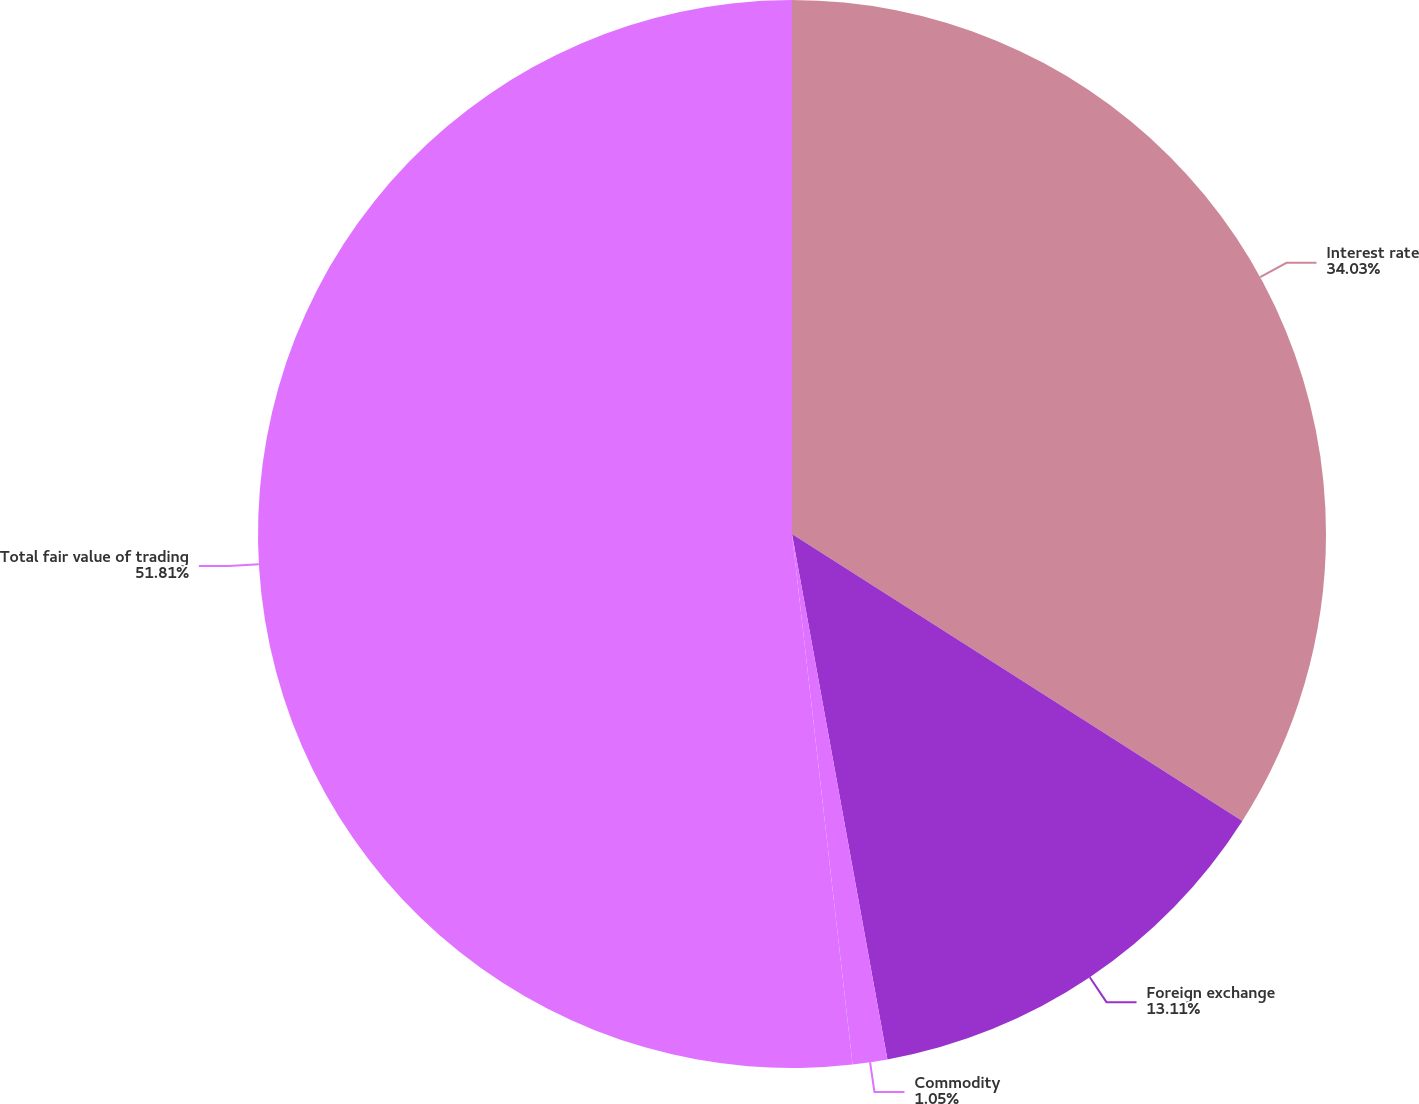Convert chart to OTSL. <chart><loc_0><loc_0><loc_500><loc_500><pie_chart><fcel>Interest rate<fcel>Foreign exchange<fcel>Commodity<fcel>Total fair value of trading<nl><fcel>34.03%<fcel>13.11%<fcel>1.05%<fcel>51.81%<nl></chart> 